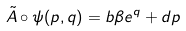<formula> <loc_0><loc_0><loc_500><loc_500>\tilde { A } \circ \psi ( p , q ) = b \beta e ^ { q } + d p</formula> 